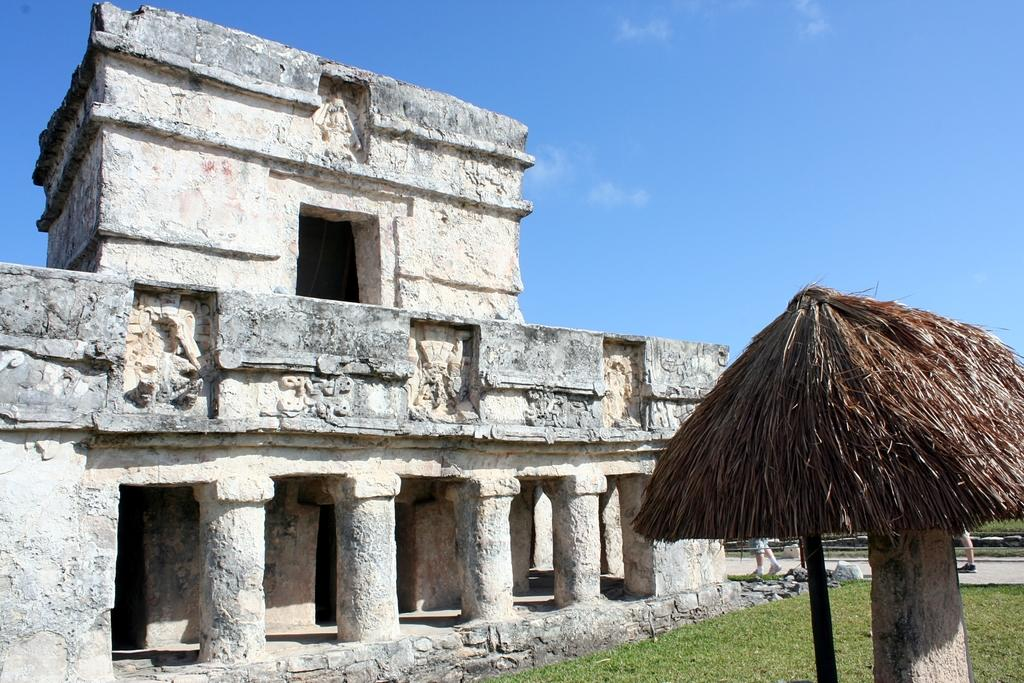What type of structure is in the image? There is a stone structure in the image. What type of vegetation is at the bottom of the image? Grass is present at the bottom of the image. What is the pole with a roof used for in the image? The pole with a roof is not specified in the image, but it could be a shelter or signpost. What is visible at the top of the image? The sky is visible at the top of the image. What type of prose is written on the stone structure in the image? There is no prose or writing visible on the stone structure in the image. Can you see a chessboard on the grass in the image? There is no chessboard present in the image. 